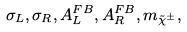Convert formula to latex. <formula><loc_0><loc_0><loc_500><loc_500>\sigma _ { L } , \sigma _ { R } , A ^ { F B } _ { L } , A ^ { F B } _ { R } , m _ { \tilde { \chi } ^ { \pm } } ,</formula> 